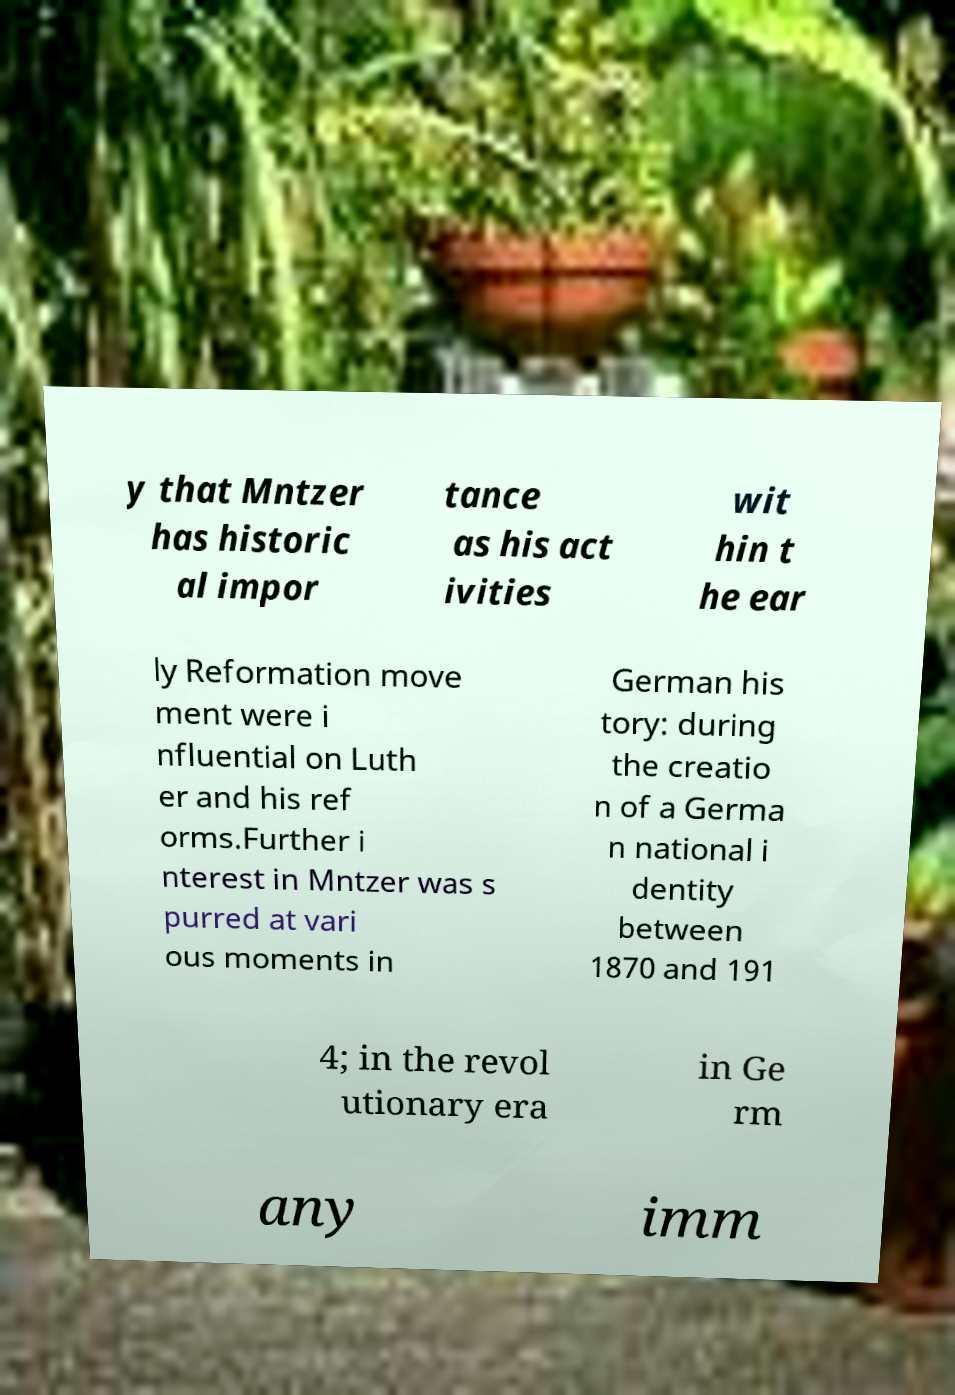Can you read and provide the text displayed in the image?This photo seems to have some interesting text. Can you extract and type it out for me? y that Mntzer has historic al impor tance as his act ivities wit hin t he ear ly Reformation move ment were i nfluential on Luth er and his ref orms.Further i nterest in Mntzer was s purred at vari ous moments in German his tory: during the creatio n of a Germa n national i dentity between 1870 and 191 4; in the revol utionary era in Ge rm any imm 